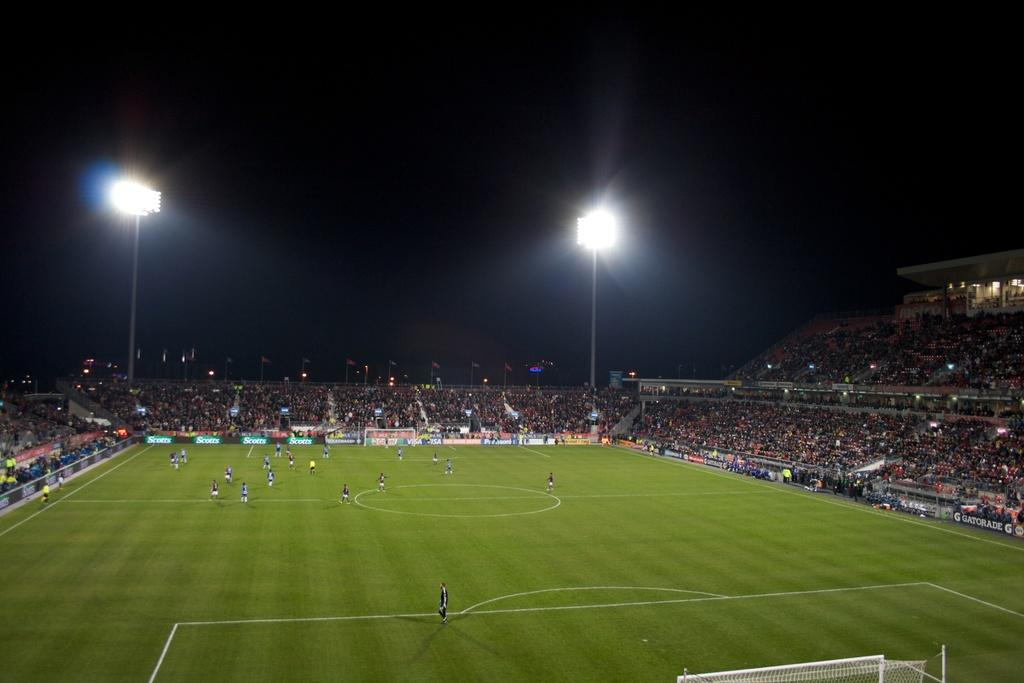What is the primary location of the persons in the image? The persons are on the ground in the image. What type of signage can be seen in the image? There are hoardings in the image. What structures are present in the image? There are poles in the image. What type of illumination is visible in the image? There are lights in the image. What type of symbolic objects can be seen in the image? There are flags in the image. How many people are present in the image? There is a crowd in the image, indicating a large number of people. What is the color of the background in the image? The background of the image is dark. Can you tell me how many twigs are being held by the crowd in the image? There are no twigs present in the image; the crowd is not holding any twigs. What type of cracker is being eaten by the person in the image? There is no person eating a cracker in the image; the focus is on the crowd and the surrounding objects. 